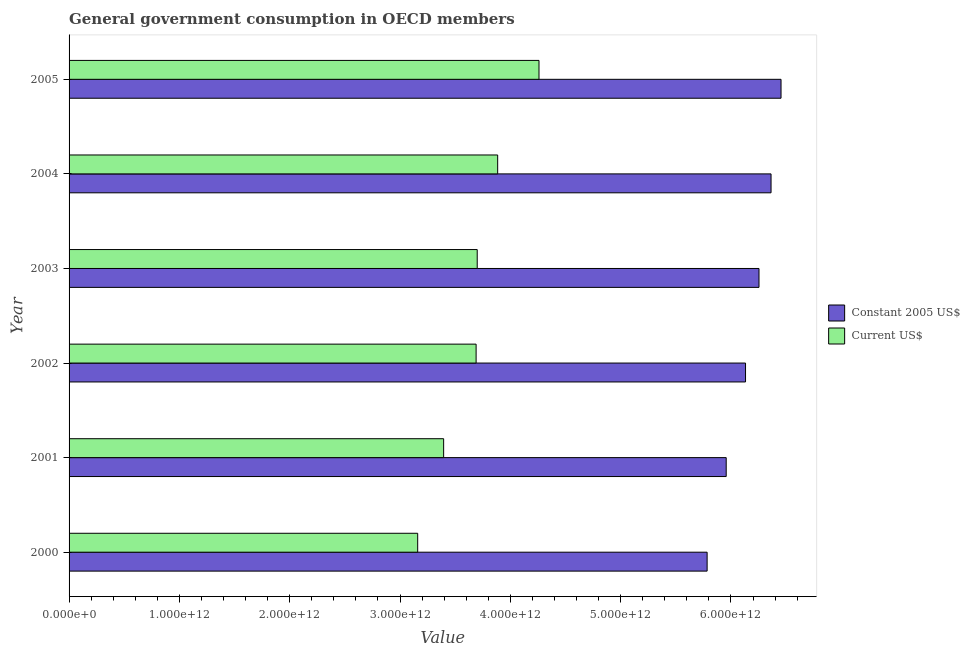How many different coloured bars are there?
Provide a short and direct response. 2. Are the number of bars per tick equal to the number of legend labels?
Keep it short and to the point. Yes. What is the label of the 1st group of bars from the top?
Give a very brief answer. 2005. What is the value consumed in constant 2005 us$ in 2004?
Give a very brief answer. 6.36e+12. Across all years, what is the maximum value consumed in current us$?
Keep it short and to the point. 4.26e+12. Across all years, what is the minimum value consumed in constant 2005 us$?
Provide a short and direct response. 5.78e+12. In which year was the value consumed in current us$ maximum?
Offer a very short reply. 2005. What is the total value consumed in current us$ in the graph?
Make the answer very short. 2.21e+13. What is the difference between the value consumed in current us$ in 2003 and that in 2004?
Keep it short and to the point. -1.85e+11. What is the difference between the value consumed in constant 2005 us$ in 2004 and the value consumed in current us$ in 2003?
Keep it short and to the point. 2.66e+12. What is the average value consumed in constant 2005 us$ per year?
Keep it short and to the point. 6.16e+12. In the year 2002, what is the difference between the value consumed in constant 2005 us$ and value consumed in current us$?
Keep it short and to the point. 2.44e+12. What is the difference between the highest and the second highest value consumed in current us$?
Ensure brevity in your answer.  3.75e+11. What is the difference between the highest and the lowest value consumed in constant 2005 us$?
Your answer should be compact. 6.70e+11. What does the 1st bar from the top in 2000 represents?
Your answer should be very brief. Current US$. What does the 2nd bar from the bottom in 2005 represents?
Keep it short and to the point. Current US$. How many bars are there?
Provide a short and direct response. 12. How many years are there in the graph?
Your answer should be compact. 6. What is the difference between two consecutive major ticks on the X-axis?
Your answer should be very brief. 1.00e+12. Are the values on the major ticks of X-axis written in scientific E-notation?
Provide a short and direct response. Yes. Does the graph contain any zero values?
Your answer should be very brief. No. Does the graph contain grids?
Offer a very short reply. No. Where does the legend appear in the graph?
Give a very brief answer. Center right. How are the legend labels stacked?
Your answer should be compact. Vertical. What is the title of the graph?
Provide a short and direct response. General government consumption in OECD members. What is the label or title of the X-axis?
Offer a very short reply. Value. What is the Value of Constant 2005 US$ in 2000?
Make the answer very short. 5.78e+12. What is the Value in Current US$ in 2000?
Offer a terse response. 3.16e+12. What is the Value in Constant 2005 US$ in 2001?
Make the answer very short. 5.96e+12. What is the Value in Current US$ in 2001?
Provide a succinct answer. 3.40e+12. What is the Value of Constant 2005 US$ in 2002?
Your answer should be compact. 6.13e+12. What is the Value in Current US$ in 2002?
Offer a very short reply. 3.69e+12. What is the Value in Constant 2005 US$ in 2003?
Ensure brevity in your answer.  6.25e+12. What is the Value of Current US$ in 2003?
Your answer should be compact. 3.70e+12. What is the Value of Constant 2005 US$ in 2004?
Offer a terse response. 6.36e+12. What is the Value in Current US$ in 2004?
Offer a terse response. 3.89e+12. What is the Value of Constant 2005 US$ in 2005?
Your answer should be very brief. 6.45e+12. What is the Value in Current US$ in 2005?
Provide a succinct answer. 4.26e+12. Across all years, what is the maximum Value in Constant 2005 US$?
Provide a succinct answer. 6.45e+12. Across all years, what is the maximum Value in Current US$?
Keep it short and to the point. 4.26e+12. Across all years, what is the minimum Value in Constant 2005 US$?
Your answer should be compact. 5.78e+12. Across all years, what is the minimum Value in Current US$?
Provide a short and direct response. 3.16e+12. What is the total Value of Constant 2005 US$ in the graph?
Give a very brief answer. 3.69e+13. What is the total Value of Current US$ in the graph?
Make the answer very short. 2.21e+13. What is the difference between the Value of Constant 2005 US$ in 2000 and that in 2001?
Your answer should be compact. -1.73e+11. What is the difference between the Value of Current US$ in 2000 and that in 2001?
Your response must be concise. -2.35e+11. What is the difference between the Value in Constant 2005 US$ in 2000 and that in 2002?
Offer a terse response. -3.48e+11. What is the difference between the Value in Current US$ in 2000 and that in 2002?
Ensure brevity in your answer.  -5.30e+11. What is the difference between the Value in Constant 2005 US$ in 2000 and that in 2003?
Offer a very short reply. -4.70e+11. What is the difference between the Value in Current US$ in 2000 and that in 2003?
Give a very brief answer. -5.40e+11. What is the difference between the Value of Constant 2005 US$ in 2000 and that in 2004?
Ensure brevity in your answer.  -5.79e+11. What is the difference between the Value in Current US$ in 2000 and that in 2004?
Offer a very short reply. -7.25e+11. What is the difference between the Value of Constant 2005 US$ in 2000 and that in 2005?
Keep it short and to the point. -6.70e+11. What is the difference between the Value of Current US$ in 2000 and that in 2005?
Your response must be concise. -1.10e+12. What is the difference between the Value in Constant 2005 US$ in 2001 and that in 2002?
Make the answer very short. -1.75e+11. What is the difference between the Value of Current US$ in 2001 and that in 2002?
Offer a terse response. -2.94e+11. What is the difference between the Value in Constant 2005 US$ in 2001 and that in 2003?
Keep it short and to the point. -2.97e+11. What is the difference between the Value in Current US$ in 2001 and that in 2003?
Make the answer very short. -3.04e+11. What is the difference between the Value in Constant 2005 US$ in 2001 and that in 2004?
Your response must be concise. -4.07e+11. What is the difference between the Value in Current US$ in 2001 and that in 2004?
Keep it short and to the point. -4.90e+11. What is the difference between the Value in Constant 2005 US$ in 2001 and that in 2005?
Make the answer very short. -4.97e+11. What is the difference between the Value in Current US$ in 2001 and that in 2005?
Give a very brief answer. -8.64e+11. What is the difference between the Value of Constant 2005 US$ in 2002 and that in 2003?
Offer a very short reply. -1.22e+11. What is the difference between the Value of Current US$ in 2002 and that in 2003?
Give a very brief answer. -1.01e+1. What is the difference between the Value of Constant 2005 US$ in 2002 and that in 2004?
Your answer should be compact. -2.31e+11. What is the difference between the Value in Current US$ in 2002 and that in 2004?
Provide a succinct answer. -1.95e+11. What is the difference between the Value in Constant 2005 US$ in 2002 and that in 2005?
Give a very brief answer. -3.22e+11. What is the difference between the Value of Current US$ in 2002 and that in 2005?
Provide a short and direct response. -5.70e+11. What is the difference between the Value in Constant 2005 US$ in 2003 and that in 2004?
Your answer should be compact. -1.09e+11. What is the difference between the Value in Current US$ in 2003 and that in 2004?
Provide a succinct answer. -1.85e+11. What is the difference between the Value in Constant 2005 US$ in 2003 and that in 2005?
Provide a succinct answer. -2.00e+11. What is the difference between the Value in Current US$ in 2003 and that in 2005?
Your response must be concise. -5.60e+11. What is the difference between the Value of Constant 2005 US$ in 2004 and that in 2005?
Keep it short and to the point. -9.06e+1. What is the difference between the Value in Current US$ in 2004 and that in 2005?
Your response must be concise. -3.75e+11. What is the difference between the Value in Constant 2005 US$ in 2000 and the Value in Current US$ in 2001?
Your answer should be very brief. 2.39e+12. What is the difference between the Value of Constant 2005 US$ in 2000 and the Value of Current US$ in 2002?
Offer a very short reply. 2.09e+12. What is the difference between the Value of Constant 2005 US$ in 2000 and the Value of Current US$ in 2003?
Provide a short and direct response. 2.08e+12. What is the difference between the Value in Constant 2005 US$ in 2000 and the Value in Current US$ in 2004?
Your answer should be very brief. 1.90e+12. What is the difference between the Value in Constant 2005 US$ in 2000 and the Value in Current US$ in 2005?
Offer a very short reply. 1.52e+12. What is the difference between the Value in Constant 2005 US$ in 2001 and the Value in Current US$ in 2002?
Make the answer very short. 2.27e+12. What is the difference between the Value in Constant 2005 US$ in 2001 and the Value in Current US$ in 2003?
Your answer should be very brief. 2.26e+12. What is the difference between the Value of Constant 2005 US$ in 2001 and the Value of Current US$ in 2004?
Offer a very short reply. 2.07e+12. What is the difference between the Value of Constant 2005 US$ in 2001 and the Value of Current US$ in 2005?
Your answer should be compact. 1.70e+12. What is the difference between the Value of Constant 2005 US$ in 2002 and the Value of Current US$ in 2003?
Make the answer very short. 2.43e+12. What is the difference between the Value in Constant 2005 US$ in 2002 and the Value in Current US$ in 2004?
Your answer should be very brief. 2.25e+12. What is the difference between the Value in Constant 2005 US$ in 2002 and the Value in Current US$ in 2005?
Make the answer very short. 1.87e+12. What is the difference between the Value in Constant 2005 US$ in 2003 and the Value in Current US$ in 2004?
Provide a short and direct response. 2.37e+12. What is the difference between the Value of Constant 2005 US$ in 2003 and the Value of Current US$ in 2005?
Your answer should be compact. 1.99e+12. What is the difference between the Value in Constant 2005 US$ in 2004 and the Value in Current US$ in 2005?
Keep it short and to the point. 2.10e+12. What is the average Value in Constant 2005 US$ per year?
Keep it short and to the point. 6.16e+12. What is the average Value in Current US$ per year?
Your answer should be compact. 3.68e+12. In the year 2000, what is the difference between the Value of Constant 2005 US$ and Value of Current US$?
Make the answer very short. 2.62e+12. In the year 2001, what is the difference between the Value of Constant 2005 US$ and Value of Current US$?
Provide a short and direct response. 2.56e+12. In the year 2002, what is the difference between the Value in Constant 2005 US$ and Value in Current US$?
Keep it short and to the point. 2.44e+12. In the year 2003, what is the difference between the Value in Constant 2005 US$ and Value in Current US$?
Offer a terse response. 2.55e+12. In the year 2004, what is the difference between the Value in Constant 2005 US$ and Value in Current US$?
Make the answer very short. 2.48e+12. In the year 2005, what is the difference between the Value in Constant 2005 US$ and Value in Current US$?
Provide a short and direct response. 2.19e+12. What is the ratio of the Value of Current US$ in 2000 to that in 2001?
Your response must be concise. 0.93. What is the ratio of the Value in Constant 2005 US$ in 2000 to that in 2002?
Ensure brevity in your answer.  0.94. What is the ratio of the Value of Current US$ in 2000 to that in 2002?
Give a very brief answer. 0.86. What is the ratio of the Value in Constant 2005 US$ in 2000 to that in 2003?
Offer a very short reply. 0.92. What is the ratio of the Value of Current US$ in 2000 to that in 2003?
Your answer should be compact. 0.85. What is the ratio of the Value of Constant 2005 US$ in 2000 to that in 2004?
Make the answer very short. 0.91. What is the ratio of the Value of Current US$ in 2000 to that in 2004?
Give a very brief answer. 0.81. What is the ratio of the Value of Constant 2005 US$ in 2000 to that in 2005?
Your response must be concise. 0.9. What is the ratio of the Value of Current US$ in 2000 to that in 2005?
Offer a terse response. 0.74. What is the ratio of the Value of Constant 2005 US$ in 2001 to that in 2002?
Provide a short and direct response. 0.97. What is the ratio of the Value in Current US$ in 2001 to that in 2002?
Provide a short and direct response. 0.92. What is the ratio of the Value in Constant 2005 US$ in 2001 to that in 2003?
Your answer should be very brief. 0.95. What is the ratio of the Value in Current US$ in 2001 to that in 2003?
Keep it short and to the point. 0.92. What is the ratio of the Value of Constant 2005 US$ in 2001 to that in 2004?
Make the answer very short. 0.94. What is the ratio of the Value in Current US$ in 2001 to that in 2004?
Offer a terse response. 0.87. What is the ratio of the Value of Constant 2005 US$ in 2001 to that in 2005?
Make the answer very short. 0.92. What is the ratio of the Value in Current US$ in 2001 to that in 2005?
Your answer should be compact. 0.8. What is the ratio of the Value of Constant 2005 US$ in 2002 to that in 2003?
Give a very brief answer. 0.98. What is the ratio of the Value of Current US$ in 2002 to that in 2003?
Make the answer very short. 1. What is the ratio of the Value in Constant 2005 US$ in 2002 to that in 2004?
Provide a short and direct response. 0.96. What is the ratio of the Value of Current US$ in 2002 to that in 2004?
Provide a succinct answer. 0.95. What is the ratio of the Value of Constant 2005 US$ in 2002 to that in 2005?
Offer a very short reply. 0.95. What is the ratio of the Value of Current US$ in 2002 to that in 2005?
Keep it short and to the point. 0.87. What is the ratio of the Value of Constant 2005 US$ in 2003 to that in 2004?
Provide a short and direct response. 0.98. What is the ratio of the Value of Current US$ in 2003 to that in 2004?
Your answer should be very brief. 0.95. What is the ratio of the Value in Constant 2005 US$ in 2003 to that in 2005?
Make the answer very short. 0.97. What is the ratio of the Value of Current US$ in 2003 to that in 2005?
Your response must be concise. 0.87. What is the ratio of the Value of Current US$ in 2004 to that in 2005?
Your answer should be very brief. 0.91. What is the difference between the highest and the second highest Value of Constant 2005 US$?
Ensure brevity in your answer.  9.06e+1. What is the difference between the highest and the second highest Value of Current US$?
Offer a terse response. 3.75e+11. What is the difference between the highest and the lowest Value of Constant 2005 US$?
Provide a succinct answer. 6.70e+11. What is the difference between the highest and the lowest Value of Current US$?
Offer a very short reply. 1.10e+12. 